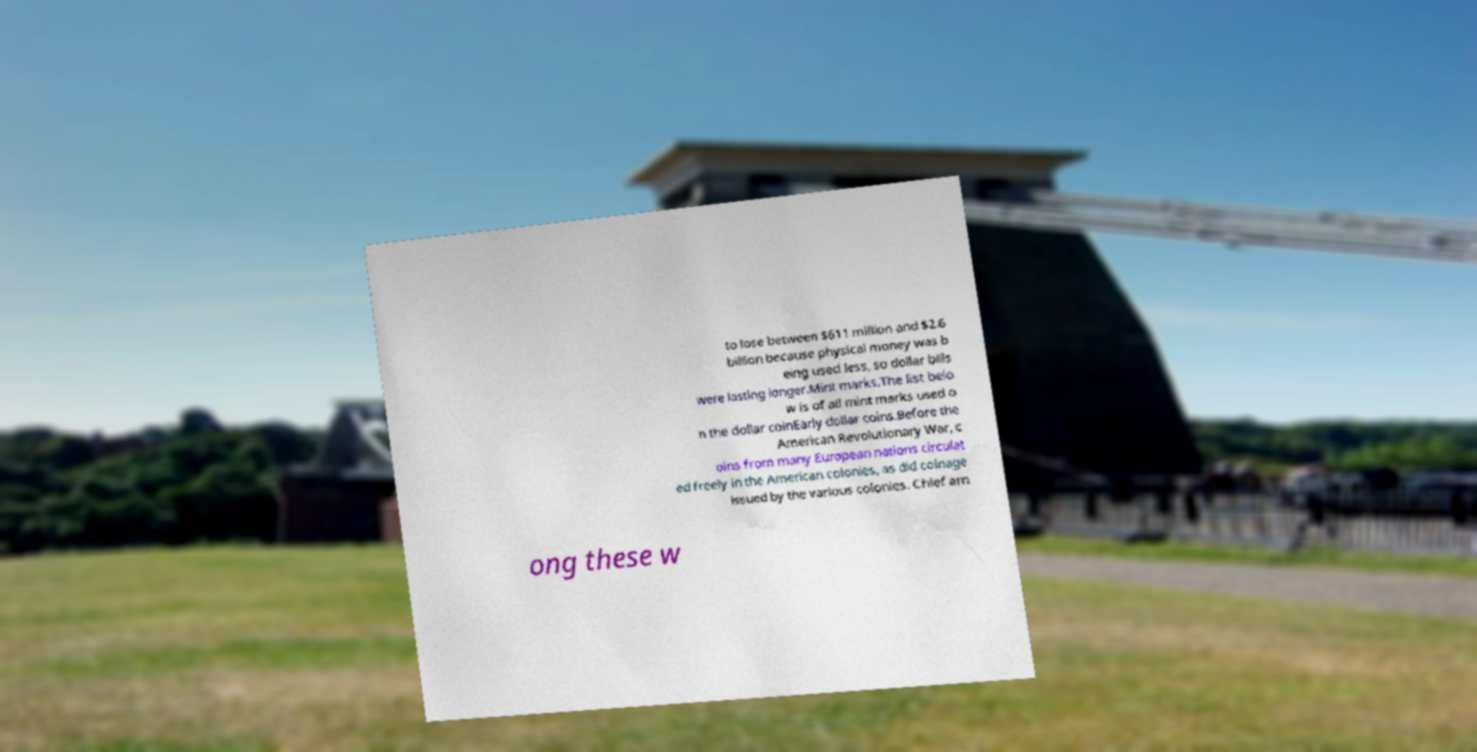I need the written content from this picture converted into text. Can you do that? to lose between $611 million and $2.6 billion because physical money was b eing used less, so dollar bills were lasting longer.Mint marks.The list belo w is of all mint marks used o n the dollar coinEarly dollar coins.Before the American Revolutionary War, c oins from many European nations circulat ed freely in the American colonies, as did coinage issued by the various colonies. Chief am ong these w 